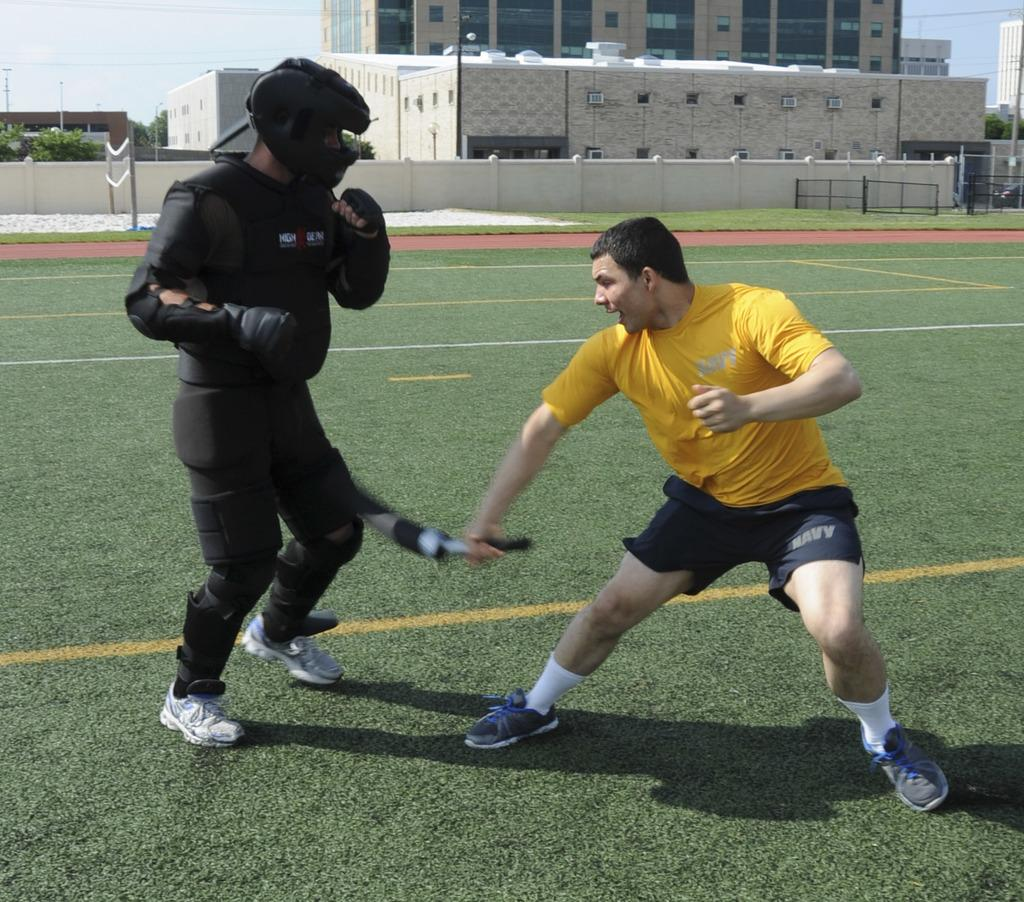<image>
Relay a brief, clear account of the picture shown. A man in Navy shorts hits another man that is in full padding. 